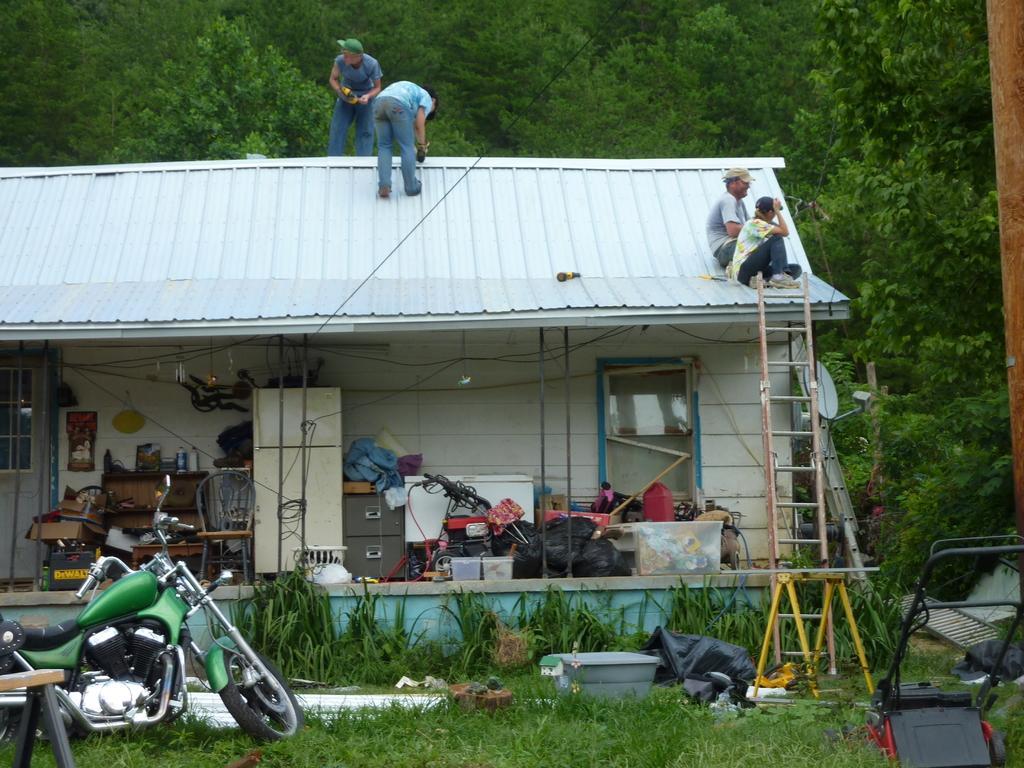How would you summarize this image in a sentence or two? In this image I can see a bike, tub, chairs, covers, metal rods on grass. In the background I can see a house, table, bags, ladder and four persons on a rooftop. At the top I can see trees. This image is taken may be during a day. 